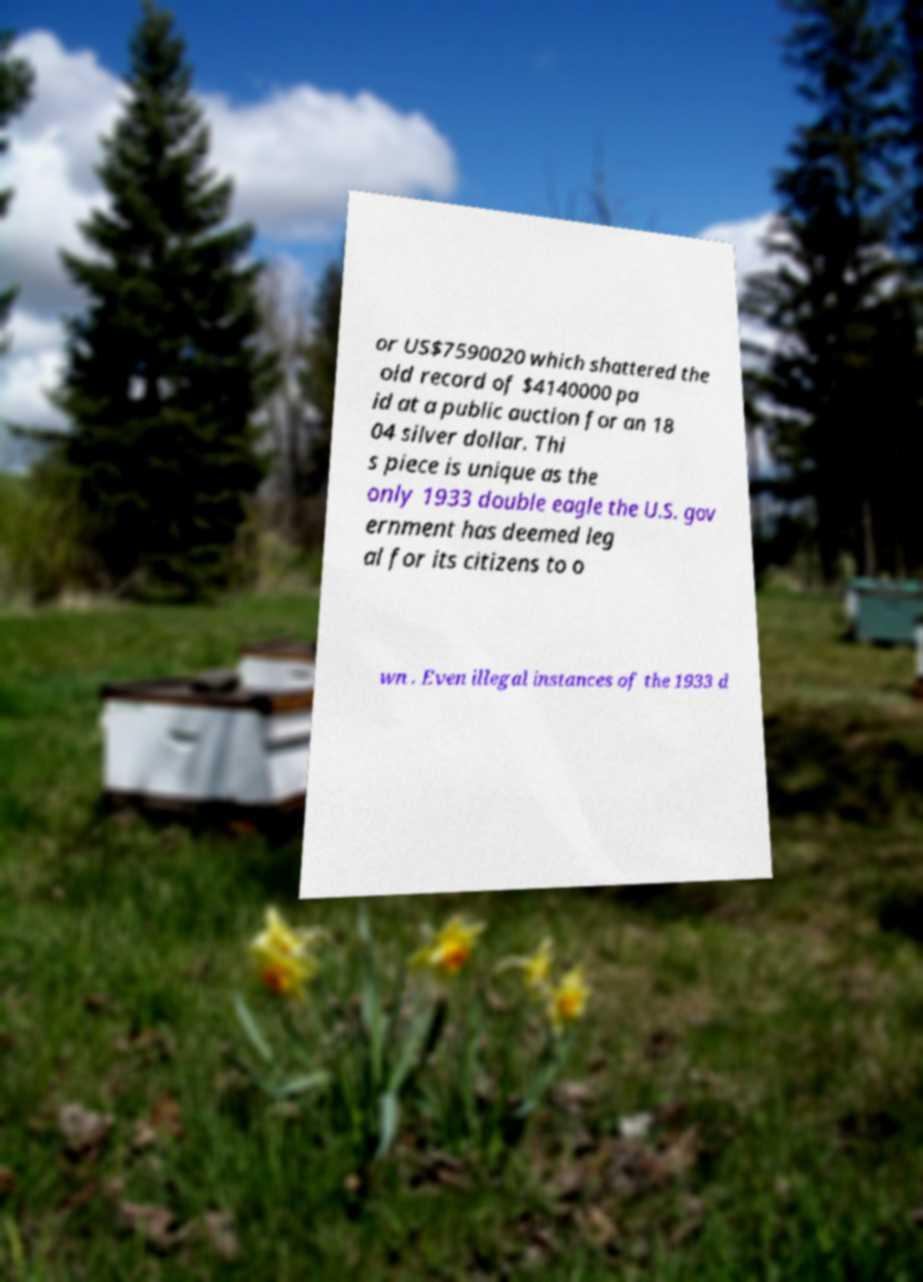I need the written content from this picture converted into text. Can you do that? or US$7590020 which shattered the old record of $4140000 pa id at a public auction for an 18 04 silver dollar. Thi s piece is unique as the only 1933 double eagle the U.S. gov ernment has deemed leg al for its citizens to o wn . Even illegal instances of the 1933 d 